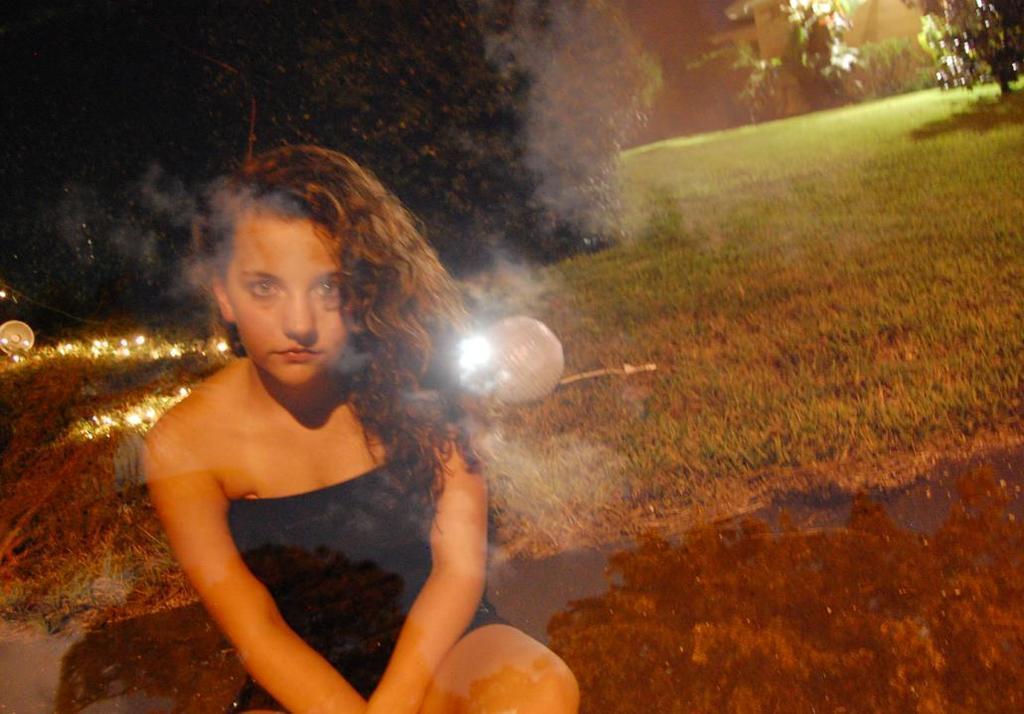Please provide a concise description of this image. On the left side of the image a girl is sitting on the ground. In the background of the image we can see some bushes, lights are there. In the middle of the image grass is present. At the bottom of the image ground is there. 